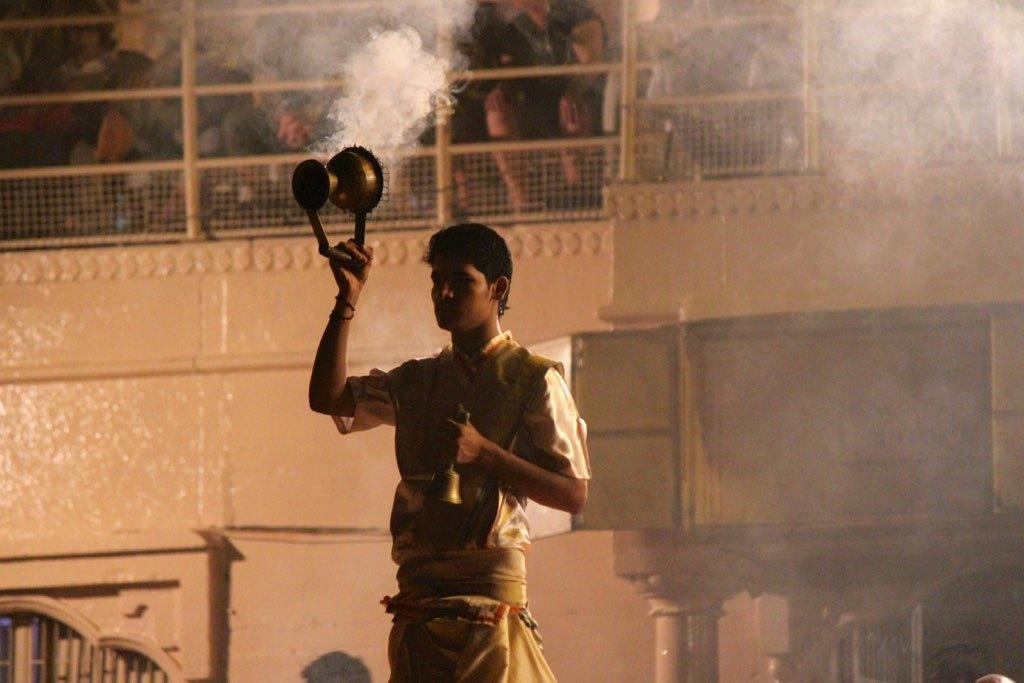What can be seen in the image? There is a person in the image. What is the person doing in the image? The person is holding an object. Can you describe the object the person is holding? There is a bell in the image. What is visible in the background of the image? There is a building in the background of the image. Are there any other people in the image? Yes, there are people inside the building. What type of jam is being spread on the person's throat in the image? There is no jam or any activity related to spreading jam on a throat in the image. 